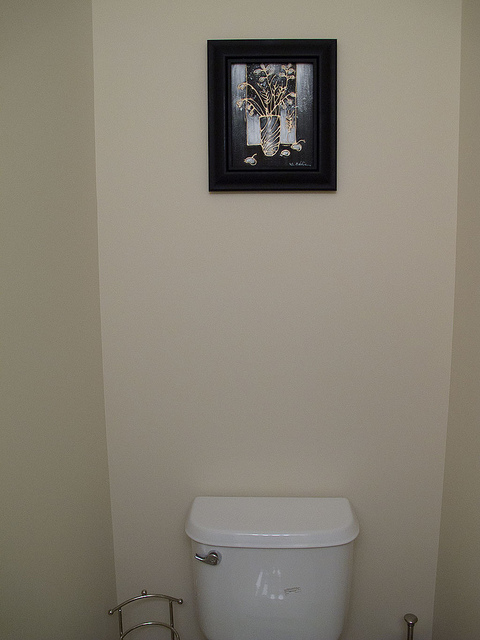What type of room is this? This appears to be a bathroom, given the presence of a toilet and a toilet paper holder. What style is the framed picture? The framed picture has a modern aesthetic with a simplistic design, depicting a still-life scene. 